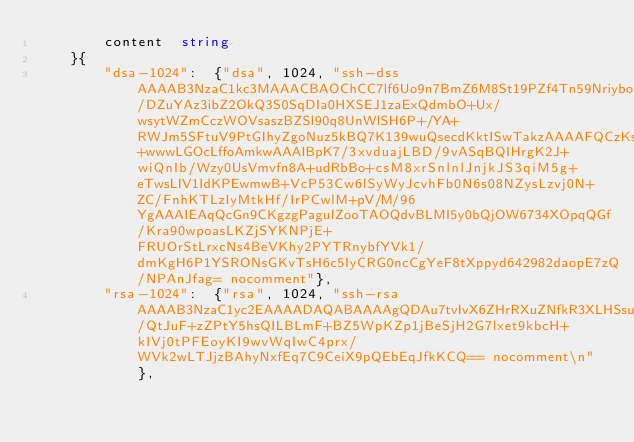<code> <loc_0><loc_0><loc_500><loc_500><_Go_>		content  string
	}{
		"dsa-1024":  {"dsa", 1024, "ssh-dss AAAAB3NzaC1kc3MAAACBAOChCC7lf6Uo9n7BmZ6M8St19PZf4Tn59NriyboW2x/DZuYAz3ibZ2OkQ3S0SqDIa0HXSEJ1zaExQdmbO+Ux/wsytWZmCczWOVsaszBZSl90q8UnWlSH6P+/YA+RWJm5SFtuV9PtGIhyZgoNuz5kBQ7K139wuQsecdKktISwTakzAAAAFQCzKsO2JhNKlL+wwwLGOcLffoAmkwAAAIBpK7/3xvduajLBD/9vASqBQIHrgK2J+wiQnIb/Wzy0UsVmvfn8A+udRbBo+csM8xrSnlnlJnjkJS3qiM5g+eTwsLIV1IdKPEwmwB+VcP53Cw6lSyWyJcvhFb0N6s08NZysLzvj0N+ZC/FnhKTLzIyMtkHf/IrPCwlM+pV/M/96YgAAAIEAqQcGn9CKgzgPaguIZooTAOQdvBLMI5y0bQjOW6734XOpqQGf/Kra90wpoasLKZjSYKNPjE+FRUOrStLrxcNs4BeVKhy2PYTRnybfYVk1/dmKgH6P1YSRONsGKvTsH6c5IyCRG0ncCgYeF8tXppyd642982daopE7zQ/NPAnJfag= nocomment"},
		"rsa-1024":  {"rsa", 1024, "ssh-rsa AAAAB3NzaC1yc2EAAAADAQABAAAAgQDAu7tvIvX6ZHrRXuZNfkR3XLHSsuCK9Zn3X58lxBcQzuo5xZgB6vRwwm/QtJuF+zZPtY5hsQILBLmF+BZ5WpKZp1jBeSjH2G7lxet9kbcH+kIVj0tPFEoyKI9wvWqIwC4prx/WVk2wLTJjzBAhyNxfEq7C9CeiX9pQEbEqJfkKCQ== nocomment\n"},</code> 